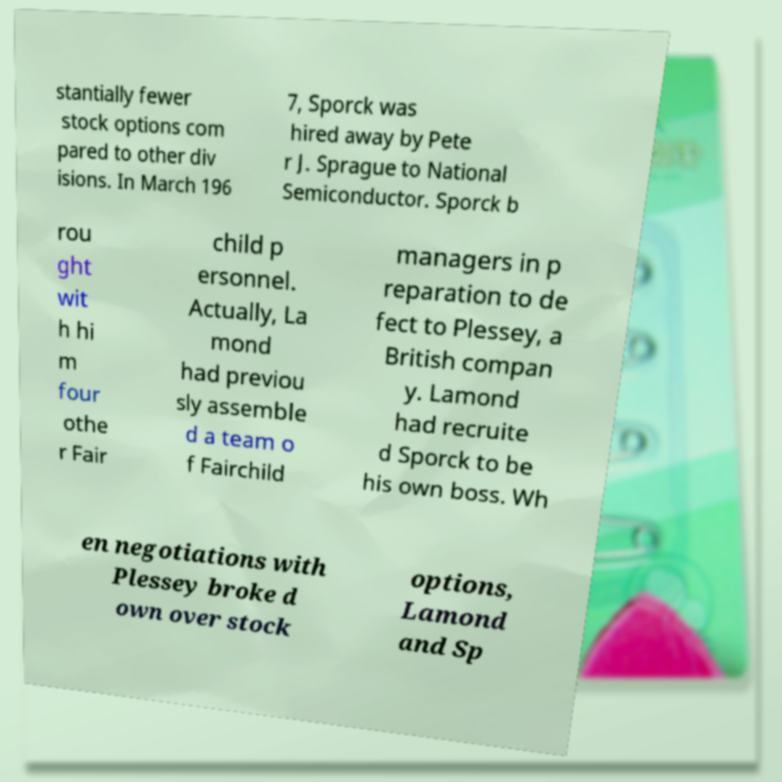For documentation purposes, I need the text within this image transcribed. Could you provide that? stantially fewer stock options com pared to other div isions. In March 196 7, Sporck was hired away by Pete r J. Sprague to National Semiconductor. Sporck b rou ght wit h hi m four othe r Fair child p ersonnel. Actually, La mond had previou sly assemble d a team o f Fairchild managers in p reparation to de fect to Plessey, a British compan y. Lamond had recruite d Sporck to be his own boss. Wh en negotiations with Plessey broke d own over stock options, Lamond and Sp 